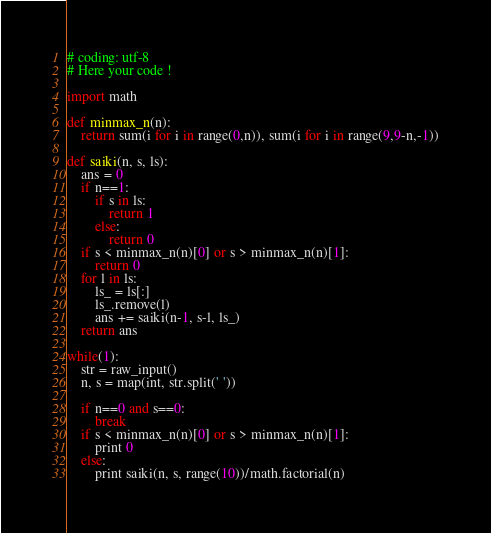Convert code to text. <code><loc_0><loc_0><loc_500><loc_500><_Python_># coding: utf-8
# Here your code !

import math

def minmax_n(n):
    return sum(i for i in range(0,n)), sum(i for i in range(9,9-n,-1))

def saiki(n, s, ls):
    ans = 0
    if n==1:
        if s in ls:
            return 1
        else:
            return 0
    if s < minmax_n(n)[0] or s > minmax_n(n)[1]:
        return 0
    for l in ls:
        ls_ = ls[:]
        ls_.remove(l)
        ans += saiki(n-1, s-l, ls_)
    return ans

while(1):
    str = raw_input()
    n, s = map(int, str.split(' '))
    
    if n==0 and s==0:
        break
    if s < minmax_n(n)[0] or s > minmax_n(n)[1]:
        print 0
    else:
        print saiki(n, s, range(10))/math.factorial(n)</code> 